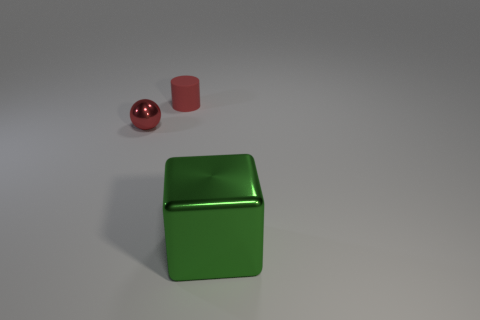Are the small cylinder and the object that is in front of the red metallic thing made of the same material?
Provide a short and direct response. No. What shape is the shiny object that is in front of the small red object in front of the red rubber object?
Give a very brief answer. Cube. What number of small things are either metallic objects or red cylinders?
Provide a succinct answer. 2. Do the red matte object and the metal object that is behind the green metallic block have the same shape?
Offer a very short reply. No. How many cubes are to the right of the block?
Provide a short and direct response. 0. Is there a thing of the same size as the red rubber cylinder?
Make the answer very short. Yes. Does the thing to the left of the cylinder have the same shape as the green object?
Your response must be concise. No. The ball has what color?
Make the answer very short. Red. There is a shiny thing that is the same color as the small cylinder; what is its shape?
Offer a very short reply. Sphere. Are any tiny red metallic balls visible?
Keep it short and to the point. Yes. 